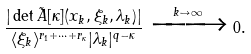<formula> <loc_0><loc_0><loc_500><loc_500>\frac { | \det \tilde { A } [ \kappa ] ( x _ { k } , \xi _ { k } , \lambda _ { k } ) | } { \langle \xi _ { k } \rangle ^ { r _ { 1 } + \dots + r _ { \kappa } } | \lambda _ { k } | ^ { q - \kappa } } \xrightarrow { k \to \infty } 0 .</formula> 